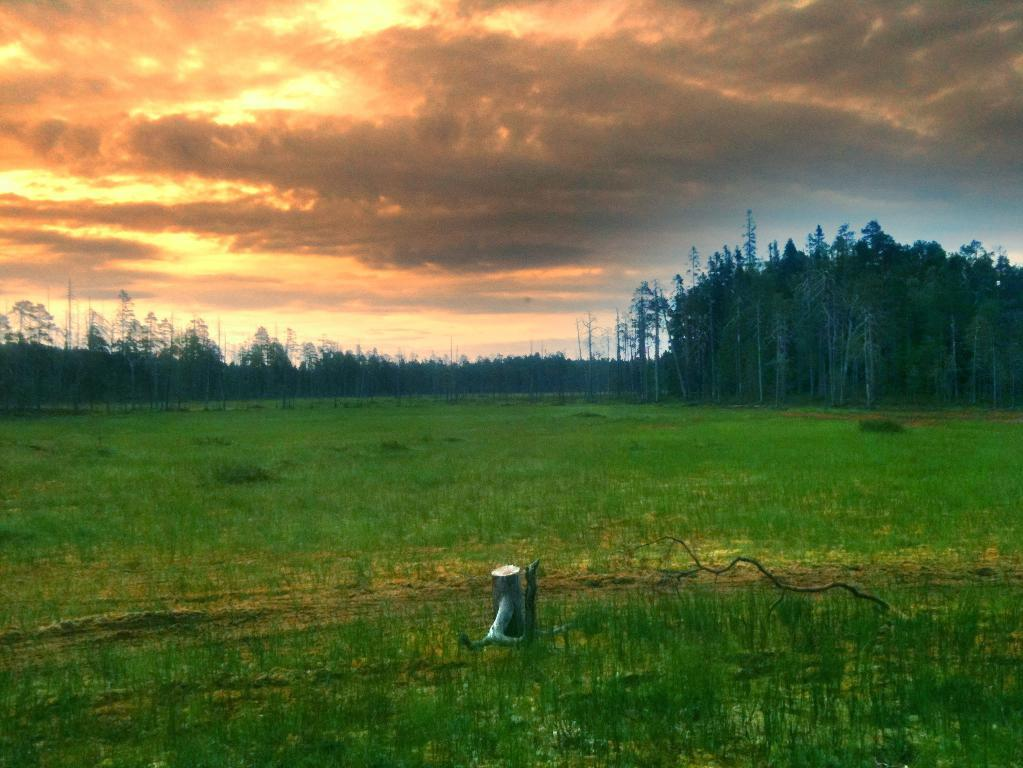What can be seen in the sky in the image? The sky is visible in the image. What is the weather like on this day? It appears to be a cloudy day. What type of vegetation is present in the image? There are trees and green grass in the image. Can you describe the branch in the image? There is a branch in the image. What object resembles a water pump in the image? There is an object that resembles a water pump at the bottom of the image. What type of needle can be seen in the image? There is no needle present in the image. Can you describe the scene taking place in the image? The image does not depict a specific scene or event; it shows a cloudy day with trees, grass, and a branch. 